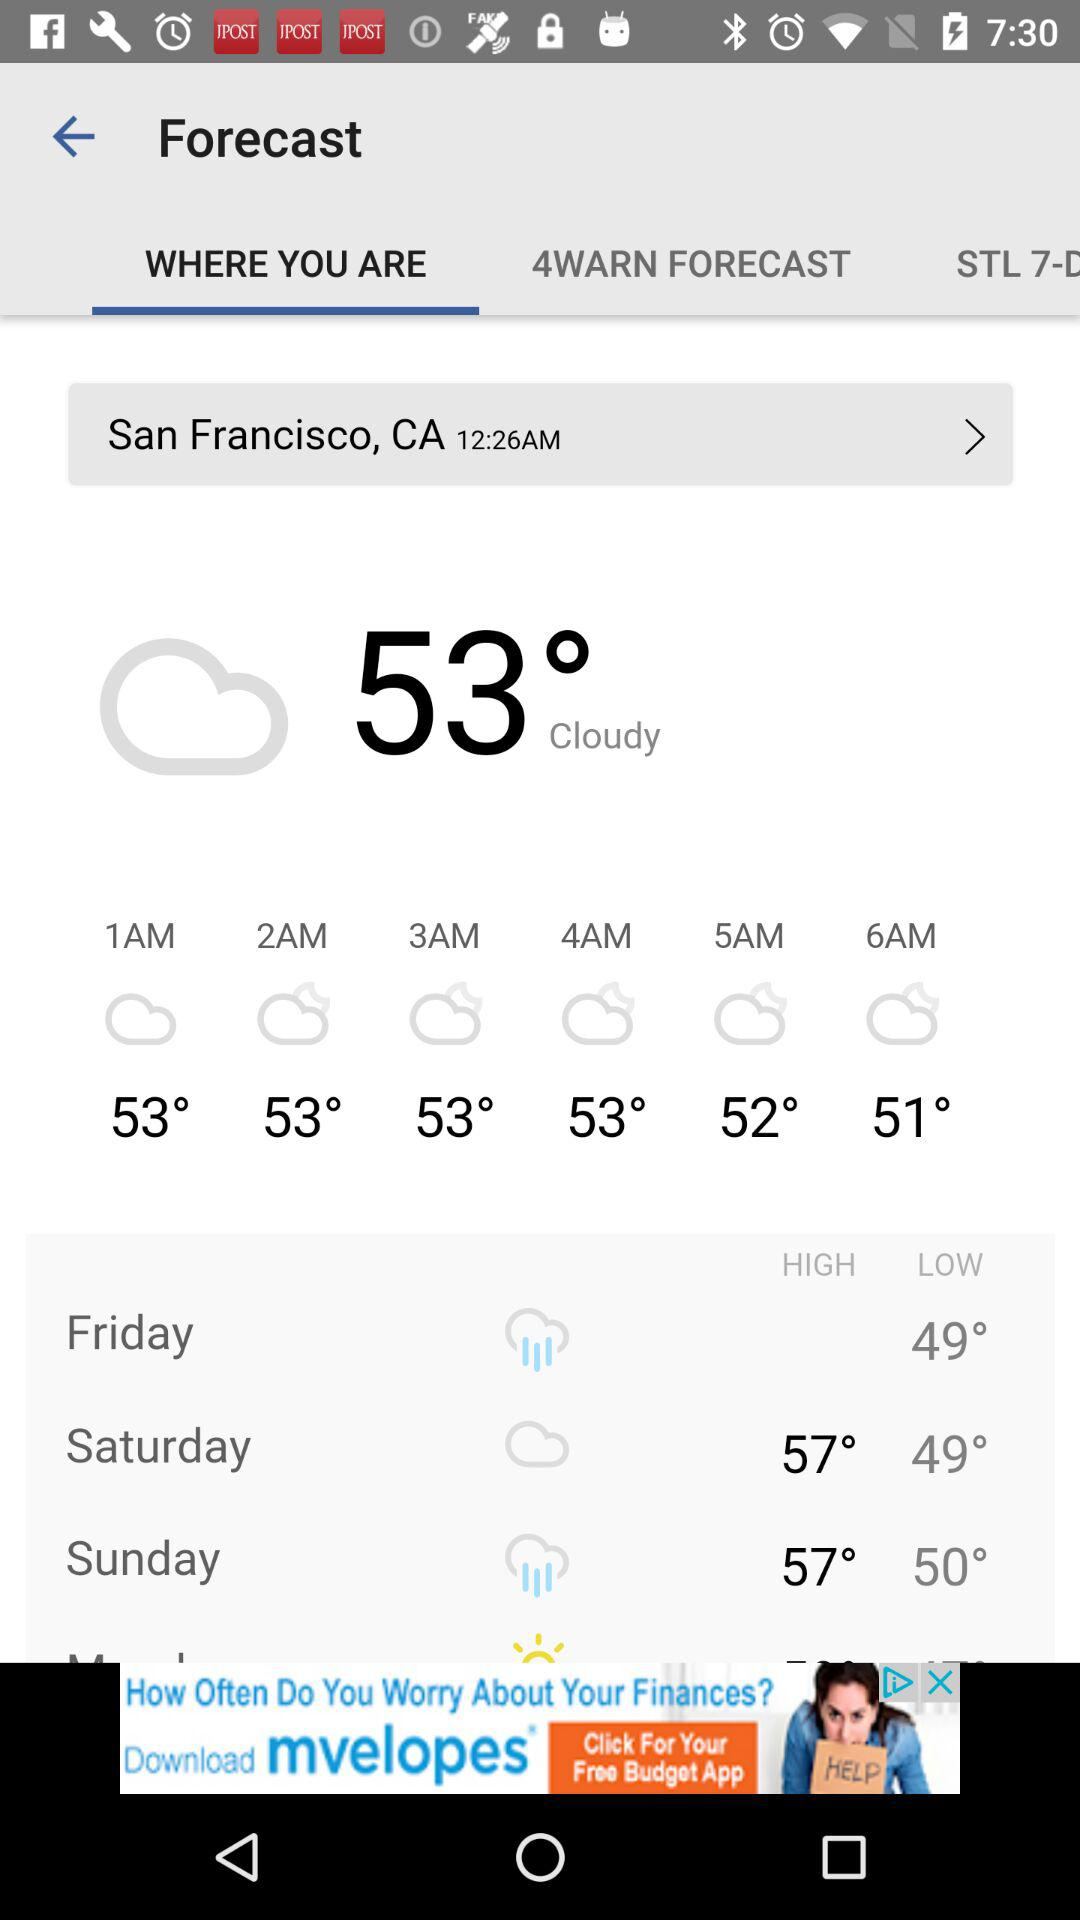What is the given time? The given time is 12:26 AM. 